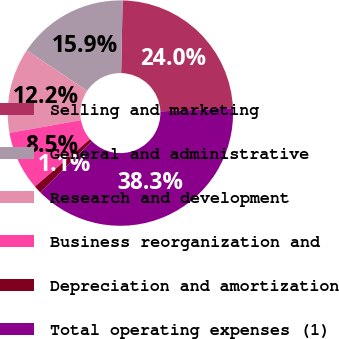Convert chart to OTSL. <chart><loc_0><loc_0><loc_500><loc_500><pie_chart><fcel>Selling and marketing<fcel>General and administrative<fcel>Research and development<fcel>Business reorganization and<fcel>Depreciation and amortization<fcel>Total operating expenses (1)<nl><fcel>24.01%<fcel>15.92%<fcel>12.21%<fcel>8.49%<fcel>1.11%<fcel>38.26%<nl></chart> 